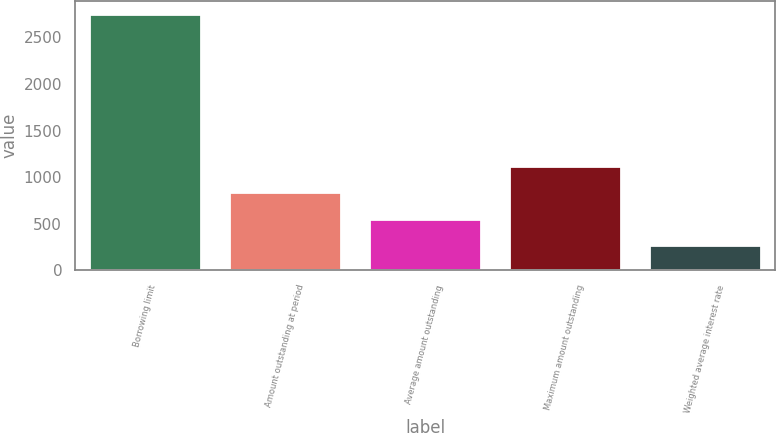Convert chart. <chart><loc_0><loc_0><loc_500><loc_500><bar_chart><fcel>Borrowing limit<fcel>Amount outstanding at period<fcel>Average amount outstanding<fcel>Maximum amount outstanding<fcel>Weighted average interest rate<nl><fcel>2750<fcel>846<fcel>550.44<fcel>1120.94<fcel>275.5<nl></chart> 